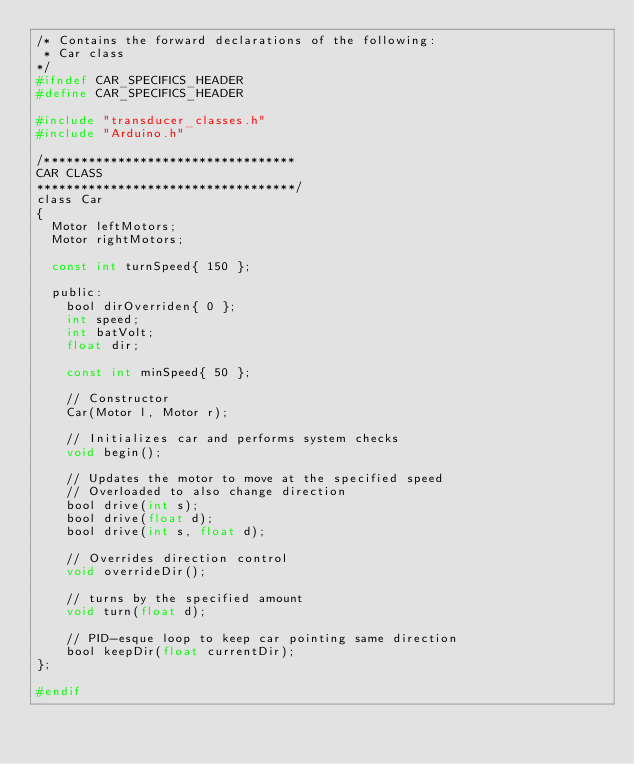<code> <loc_0><loc_0><loc_500><loc_500><_C_>/* Contains the forward declarations of the following:
 * Car class
*/
#ifndef CAR_SPECIFICS_HEADER
#define CAR_SPECIFICS_HEADER

#include "transducer_classes.h"
#include "Arduino.h"

/**********************************
CAR CLASS
***********************************/
class Car
{
  Motor leftMotors;
  Motor rightMotors;

  const int turnSpeed{ 150 };

  public:
    bool dirOverriden{ 0 };
    int speed;
    int batVolt;
    float dir;

    const int minSpeed{ 50 };

    // Constructor
    Car(Motor l, Motor r);

    // Initializes car and performs system checks
    void begin();

    // Updates the motor to move at the specified speed
    // Overloaded to also change direction
    bool drive(int s);
    bool drive(float d);
    bool drive(int s, float d);

    // Overrides direction control
    void overrideDir();

    // turns by the specified amount
    void turn(float d);

    // PID-esque loop to keep car pointing same direction
    bool keepDir(float currentDir);
};

#endif
</code> 